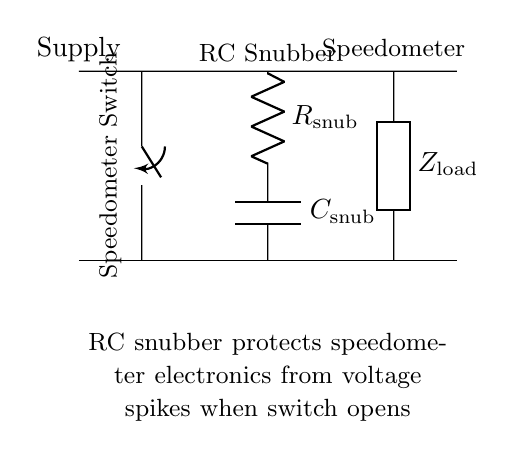What is the primary function of the RC snubber in this circuit? The RC snubber is used to protect the speedometer electronics from voltage spikes when the switch opens, preventing potential damage.
Answer: Protect electronics What component is located in series with the switch? The switch is connected in series with the speedometer, meaning it directly controls the flow of electricity to it.
Answer: Speedometer switch What type of component is used as the load in this circuit? The load in this circuit is represented by a generic component labeled as Z load, denoting that it can be any type of electrical appliance or load that the circuit powers.
Answer: Load How many components are present in the RC snubber? The RC snubber consists of two components: a resistor and a capacitor, which work together to manage voltage spikes.
Answer: Two What is the placement of the resistor in relation to the capacitor? The resistor is placed above the capacitor in the schematic, indicating that it is encountered first in the pathway of the electrical current.
Answer: Above Why is it important to use an RC snubber in a speedometer circuit? An RC snubber is essential in a speedometer circuit to absorb and dissipate voltage spikes when the switch is opened, which could otherwise damage sensitive electronic components.
Answer: Prevents damage 